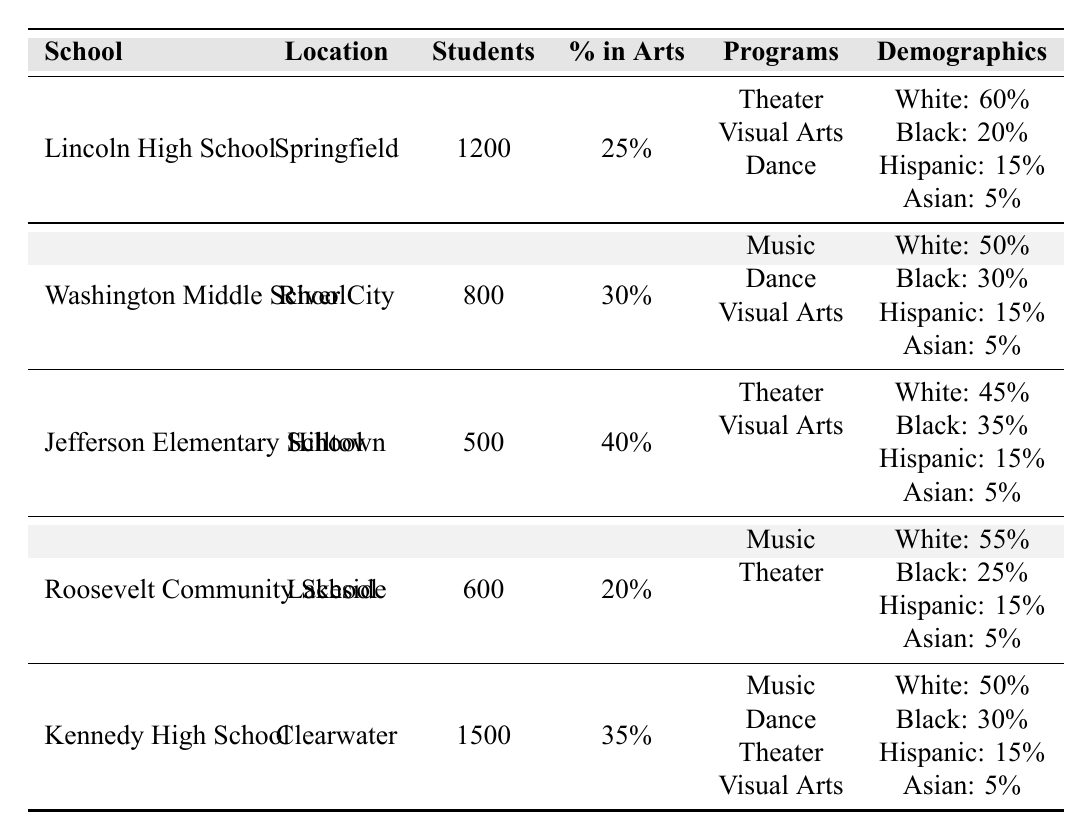What is the student population of Lincoln High School? The table lists Lincoln High School with a student population of 1200 in the relevant column.
Answer: 1200 What percentage of students at Jefferson Elementary School are enrolled in arts programs? According to the table, Jefferson Elementary School has 40% of its students participating in arts programs.
Answer: 40% Which school has the highest percentage of students involved in arts programs? By comparing the percentages in the table, Jefferson Elementary School has the highest at 40%.
Answer: Jefferson Elementary School Is the majority of the student population in Washington Middle School black? The table shows that 30% of Washington Middle School's students are black. This is not a majority, as white students represent 50%.
Answer: No What is the total percentage of students of color (black, Hispanic, and Asian) at Kennedy High School? Adding the percentages: Black (30%) + Hispanic (15%) + Asian (5%) gives a total of 50% of students of color.
Answer: 50% Which school offers the least variety in arts programs? The table indicates that Roosevelt Community School offers only two types of arts programs (Music and Theater), while other schools offer more.
Answer: Roosevelt Community School What is the difference in the proportion of Hispanic students between Lincoln High School and Washington Middle School? Lincoln High School has 15% Hispanic students and Washington Middle School also has 15%. The difference between them is 0%.
Answer: 0% If we consider only Washington Middle School and Kennedy High School, which school has a higher total percentage of white students? Washington Middle School has 50% white students, while Kennedy High School has 50%. The percentages are equal.
Answer: Equal Do more than half of the students at Jefferson Elementary School participate in arts programs? Jefferson Elementary School has 40% of its student population in arts programs, which is not more than half (50%).
Answer: No What is the average percentage of students in arts programs across all schools listed? To find the average, sum the percentages: 25 + 30 + 40 + 20 + 35 = 150, then divide by 5 (the number of schools), giving an average of 30%.
Answer: 30% 